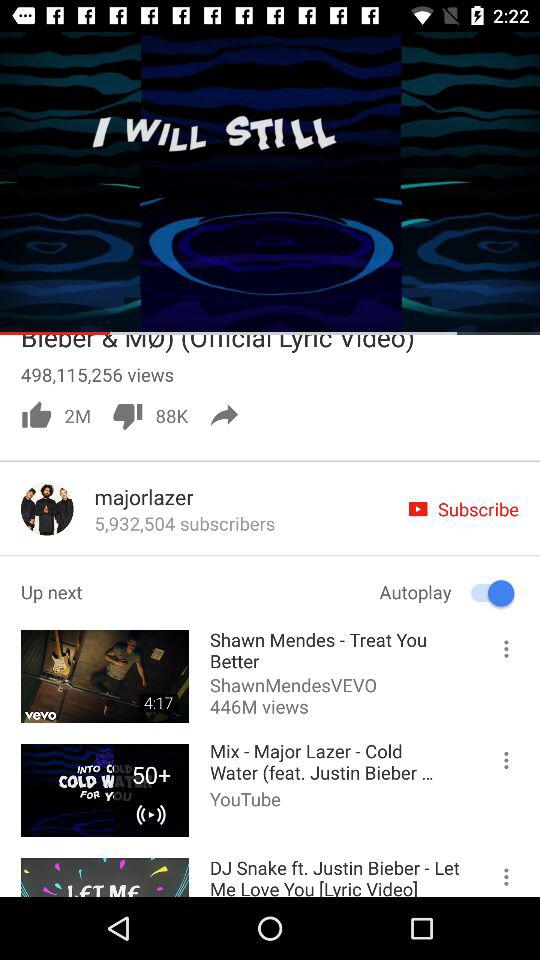How many views are there of "Coldplay - Hymn For The Weekend"? There are 619,460,440 views of "Coldplay - Hymn For The Weekend". 